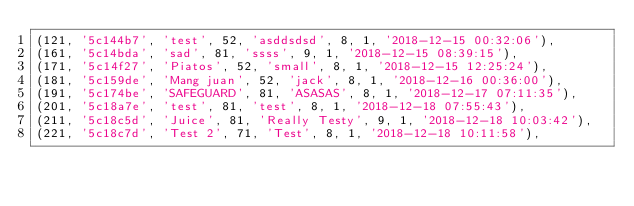Convert code to text. <code><loc_0><loc_0><loc_500><loc_500><_SQL_>(121, '5c144b7', 'test', 52, 'asddsdsd', 8, 1, '2018-12-15 00:32:06'),
(161, '5c14bda', 'sad', 81, 'ssss', 9, 1, '2018-12-15 08:39:15'),
(171, '5c14f27', 'Piatos', 52, 'small', 8, 1, '2018-12-15 12:25:24'),
(181, '5c159de', 'Mang juan', 52, 'jack', 8, 1, '2018-12-16 00:36:00'),
(191, '5c174be', 'SAFEGUARD', 81, 'ASASAS', 8, 1, '2018-12-17 07:11:35'),
(201, '5c18a7e', 'test', 81, 'test', 8, 1, '2018-12-18 07:55:43'),
(211, '5c18c5d', 'Juice', 81, 'Really Testy', 9, 1, '2018-12-18 10:03:42'),
(221, '5c18c7d', 'Test 2', 71, 'Test', 8, 1, '2018-12-18 10:11:58'),</code> 